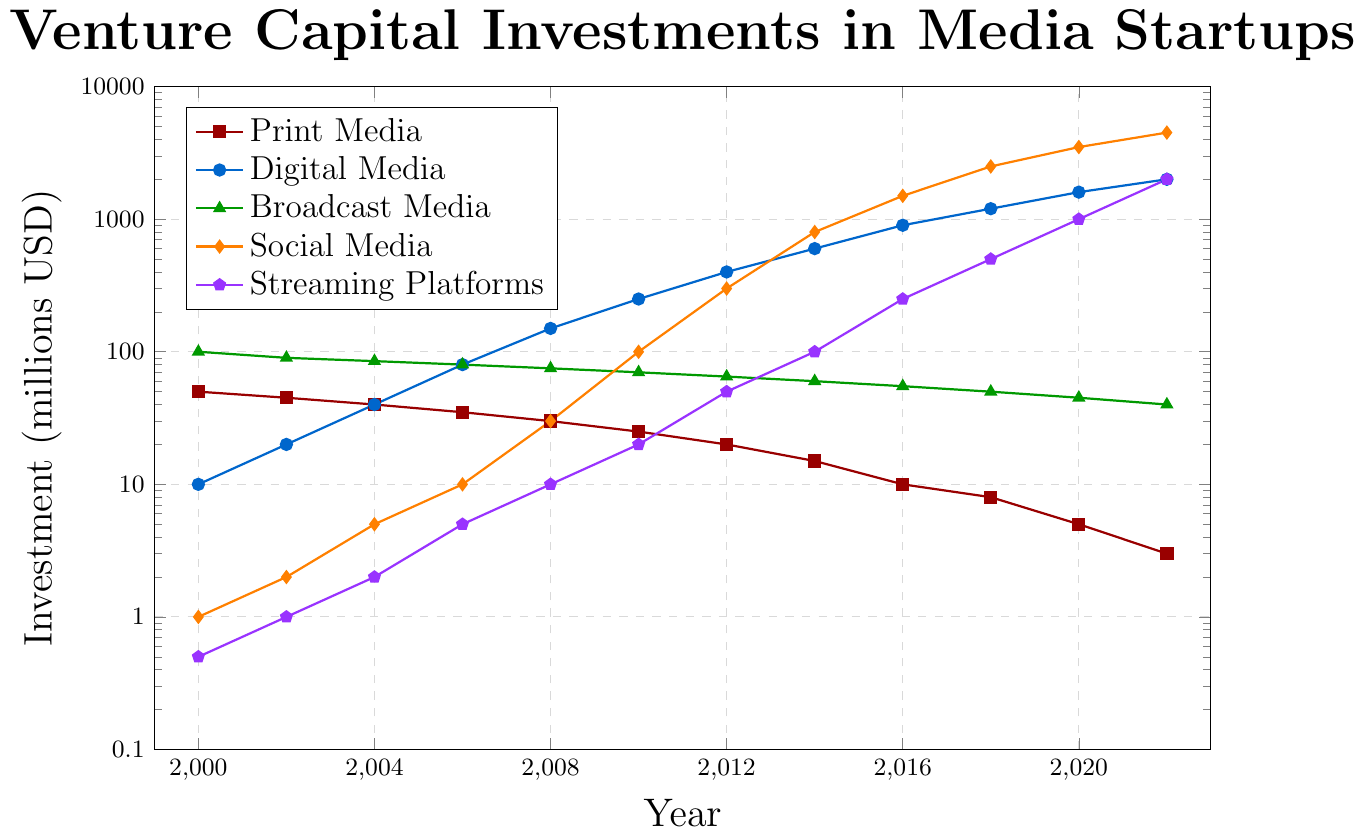What trend can we observe in Venture Capital investments for Print Media from 2000 to 2022? By observing the Print Media investment data on the logscale chart, we can see a consistent decline over the years. Starting at 50 million USD in 2000, it decreases steadily to 3 million USD in 2022.
Answer: Consistent decline Which media type had the highest investment in 2022? Referring to the top point of each series in the year 2022, we observe that Social Media had the highest investment amounting to 4500 million USD.
Answer: Social Media In which year did Digital Media surpass 1000 million USD in investments? Looking at the logscale chart, the yellow line representing Digital Media crosses the 1000 million USD mark between 2016 and 2018. Thus, Digital Media investments surpassed 1000 million USD in 2018.
Answer: 2018 How do investments in Social Media and Streaming Platforms compare from 2016 to 2022? For Social Media, investments rose from 1500 million USD in 2016 to 4500 million USD in 2022. For Streaming Platforms, investments increased from 250 million USD in 2016 to 2000 million USD in 2022. Social Media saw a sharper increase compared to Streaming Platforms.
Answer: Social Media saw a sharper increase What is the difference in investment between Broadcasting Media and Streaming Platforms in 2008? In 2008, Broadcasting Media received 75 million USD and Streaming Platforms received 10 million USD. The difference is calculated as 75 million USD - 10 million USD.
Answer: 65 million USD How does the investment trend in Digital Media from 2008 to 2014 compare to the investment trend in Print Media during the same period? Between 2008 and 2014, Digital Media investments rose from 150 million USD to 600 million USD, while Print Media investments fell from 30 million USD to 15 million USD.
Answer: Digital Media rose, Print Media fell Which media type had the least variation in investments from 2000 to 2022? Based on the logscale chart, Broadcasting Media shows the least variation, maintaining investments within a relatively narrow range from 40 to 100 million USD over the years.
Answer: Broadcast Media What is the average investment in Digital Media across the entire period? Averaging the investments for Digital Media across all years: (10 + 20 + 40 + 80 + 150 + 250 + 400 + 600 + 900 + 1200 + 1600 + 2000) / 12. The sum is 7250 million USD, so the average is 7250 / 12.
Answer: 604.17 million USD What is the growth rate of investments in Streaming Platforms from 2014 to 2018? The investment grew from 100 million USD in 2014 to 500 million USD in 2018. The ratio of the final to initial investment is 500 / 100 = 5. Thus, the growth rate over this period is (5 - 1) * 100%.
Answer: 400% If we sum the investments of Print Media and Broadcasting Media in 2020, what would be the total? Summing the investments for Print Media (5 million USD) and Broadcasting Media (45 million USD) gives us the total investment.
Answer: 50 million USD 